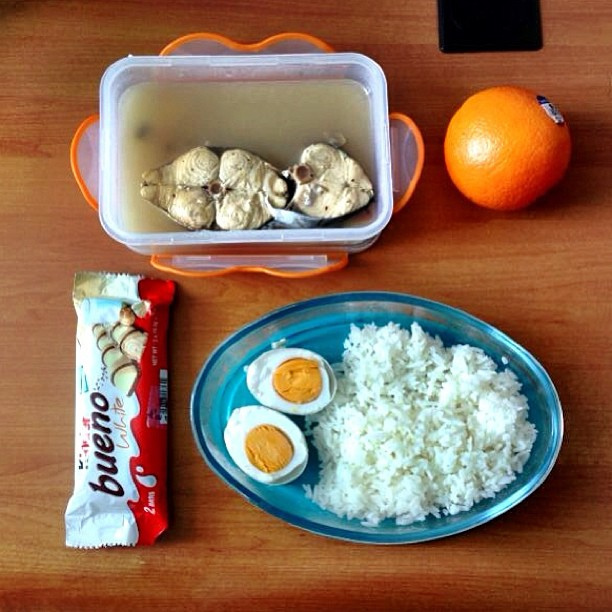Extract all visible text content from this image. BUENO 